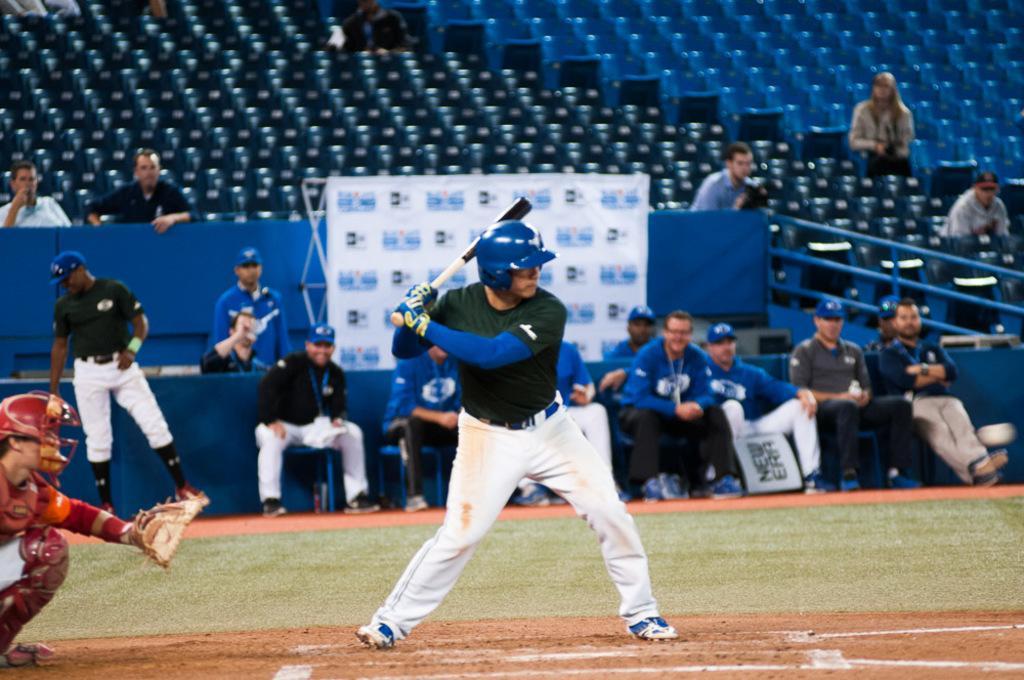How would you summarize this image in a sentence or two? In this picture we can see a person standing on the ground,holding a bat and in the background we can see people. 